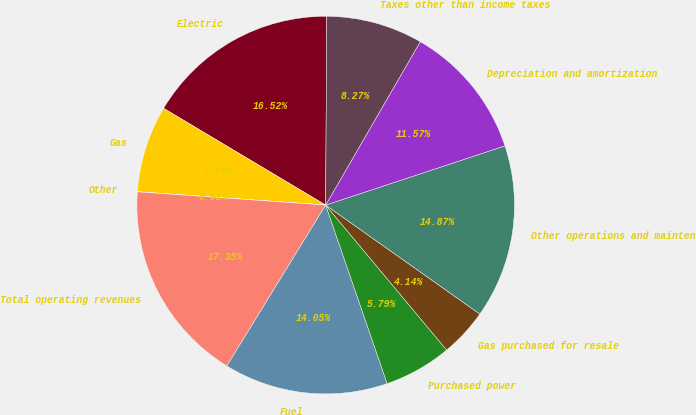<chart> <loc_0><loc_0><loc_500><loc_500><pie_chart><fcel>Electric<fcel>Gas<fcel>Other<fcel>Total operating revenues<fcel>Fuel<fcel>Purchased power<fcel>Gas purchased for resale<fcel>Other operations and mainten<fcel>Depreciation and amortization<fcel>Taxes other than income taxes<nl><fcel>16.52%<fcel>7.44%<fcel>0.01%<fcel>17.35%<fcel>14.05%<fcel>5.79%<fcel>4.14%<fcel>14.87%<fcel>11.57%<fcel>8.27%<nl></chart> 